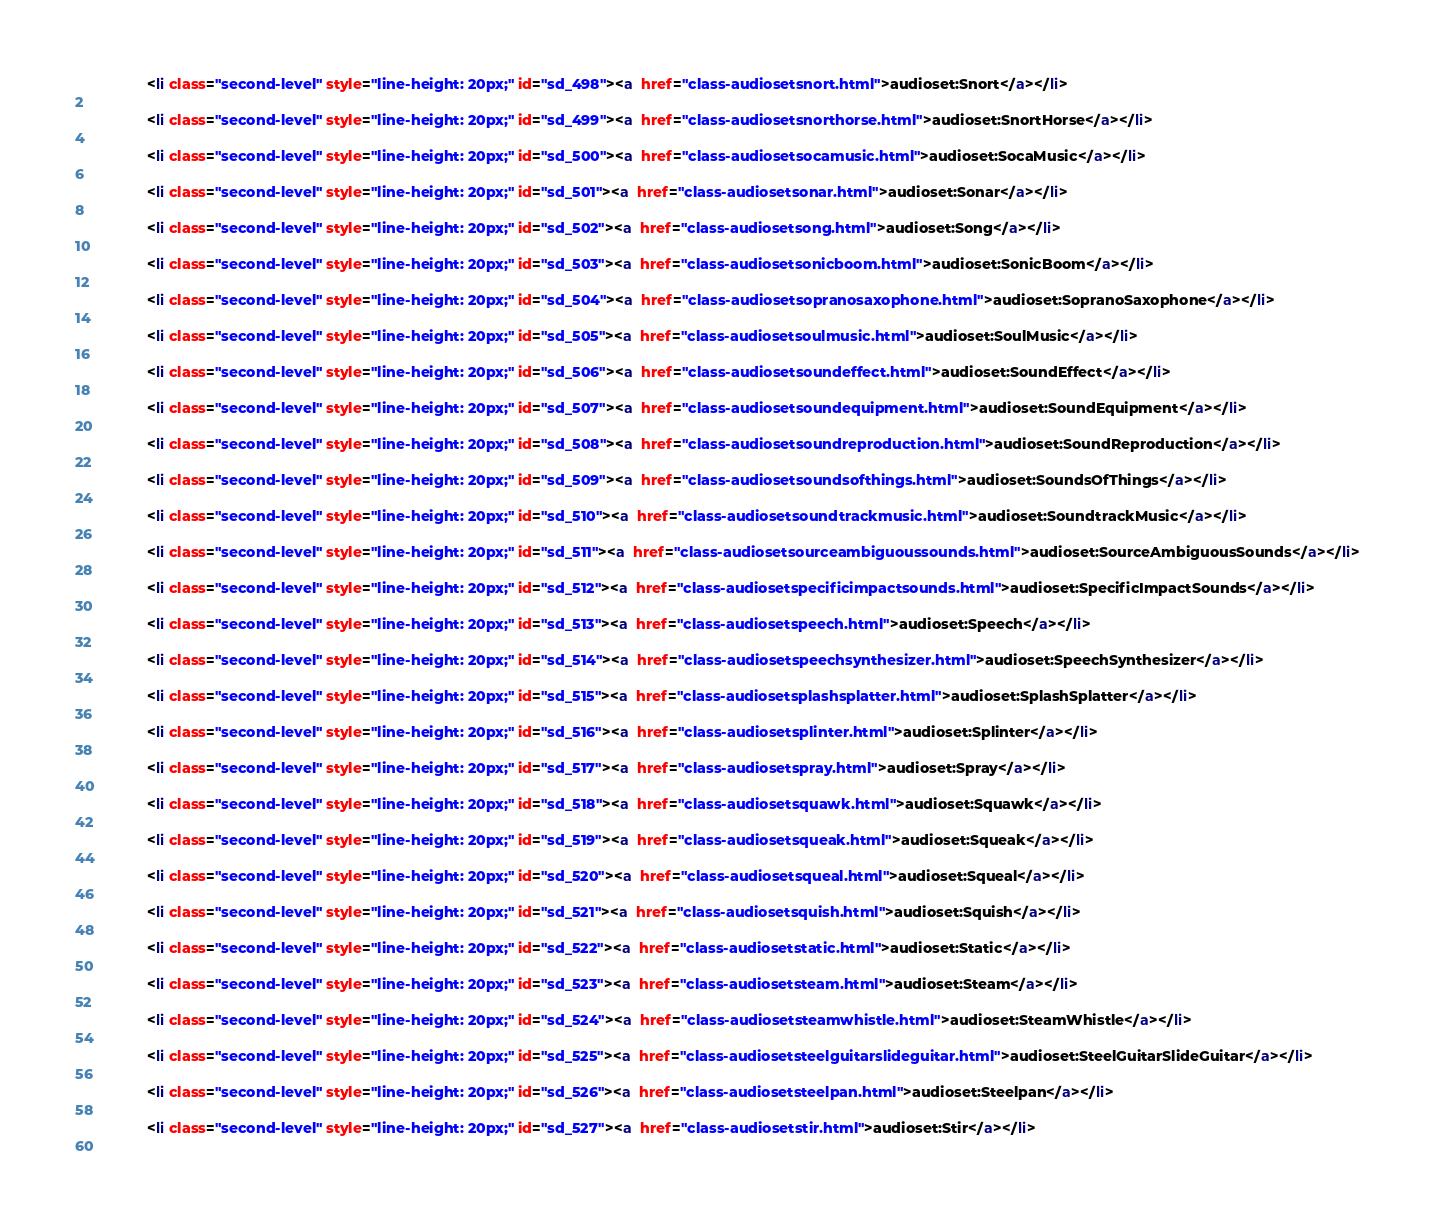Convert code to text. <code><loc_0><loc_0><loc_500><loc_500><_HTML_>              <li class="second-level" style="line-height: 20px;" id="sd_498"><a  href="class-audiosetsnort.html">audioset:Snort</a></li>
          
              <li class="second-level" style="line-height: 20px;" id="sd_499"><a  href="class-audiosetsnorthorse.html">audioset:SnortHorse</a></li>
          
              <li class="second-level" style="line-height: 20px;" id="sd_500"><a  href="class-audiosetsocamusic.html">audioset:SocaMusic</a></li>
          
              <li class="second-level" style="line-height: 20px;" id="sd_501"><a  href="class-audiosetsonar.html">audioset:Sonar</a></li>
          
              <li class="second-level" style="line-height: 20px;" id="sd_502"><a  href="class-audiosetsong.html">audioset:Song</a></li>
          
              <li class="second-level" style="line-height: 20px;" id="sd_503"><a  href="class-audiosetsonicboom.html">audioset:SonicBoom</a></li>
          
              <li class="second-level" style="line-height: 20px;" id="sd_504"><a  href="class-audiosetsopranosaxophone.html">audioset:SopranoSaxophone</a></li>
          
              <li class="second-level" style="line-height: 20px;" id="sd_505"><a  href="class-audiosetsoulmusic.html">audioset:SoulMusic</a></li>
          
              <li class="second-level" style="line-height: 20px;" id="sd_506"><a  href="class-audiosetsoundeffect.html">audioset:SoundEffect</a></li>
          
              <li class="second-level" style="line-height: 20px;" id="sd_507"><a  href="class-audiosetsoundequipment.html">audioset:SoundEquipment</a></li>
          
              <li class="second-level" style="line-height: 20px;" id="sd_508"><a  href="class-audiosetsoundreproduction.html">audioset:SoundReproduction</a></li>
          
              <li class="second-level" style="line-height: 20px;" id="sd_509"><a  href="class-audiosetsoundsofthings.html">audioset:SoundsOfThings</a></li>
          
              <li class="second-level" style="line-height: 20px;" id="sd_510"><a  href="class-audiosetsoundtrackmusic.html">audioset:SoundtrackMusic</a></li>
          
              <li class="second-level" style="line-height: 20px;" id="sd_511"><a  href="class-audiosetsourceambiguoussounds.html">audioset:SourceAmbiguousSounds</a></li>
          
              <li class="second-level" style="line-height: 20px;" id="sd_512"><a  href="class-audiosetspecificimpactsounds.html">audioset:SpecificImpactSounds</a></li>
          
              <li class="second-level" style="line-height: 20px;" id="sd_513"><a  href="class-audiosetspeech.html">audioset:Speech</a></li>
          
              <li class="second-level" style="line-height: 20px;" id="sd_514"><a  href="class-audiosetspeechsynthesizer.html">audioset:SpeechSynthesizer</a></li>
          
              <li class="second-level" style="line-height: 20px;" id="sd_515"><a  href="class-audiosetsplashsplatter.html">audioset:SplashSplatter</a></li>
          
              <li class="second-level" style="line-height: 20px;" id="sd_516"><a  href="class-audiosetsplinter.html">audioset:Splinter</a></li>
          
              <li class="second-level" style="line-height: 20px;" id="sd_517"><a  href="class-audiosetspray.html">audioset:Spray</a></li>
          
              <li class="second-level" style="line-height: 20px;" id="sd_518"><a  href="class-audiosetsquawk.html">audioset:Squawk</a></li>
          
              <li class="second-level" style="line-height: 20px;" id="sd_519"><a  href="class-audiosetsqueak.html">audioset:Squeak</a></li>
          
              <li class="second-level" style="line-height: 20px;" id="sd_520"><a  href="class-audiosetsqueal.html">audioset:Squeal</a></li>
          
              <li class="second-level" style="line-height: 20px;" id="sd_521"><a  href="class-audiosetsquish.html">audioset:Squish</a></li>
          
              <li class="second-level" style="line-height: 20px;" id="sd_522"><a  href="class-audiosetstatic.html">audioset:Static</a></li>
          
              <li class="second-level" style="line-height: 20px;" id="sd_523"><a  href="class-audiosetsteam.html">audioset:Steam</a></li>
          
              <li class="second-level" style="line-height: 20px;" id="sd_524"><a  href="class-audiosetsteamwhistle.html">audioset:SteamWhistle</a></li>
          
              <li class="second-level" style="line-height: 20px;" id="sd_525"><a  href="class-audiosetsteelguitarslideguitar.html">audioset:SteelGuitarSlideGuitar</a></li>
          
              <li class="second-level" style="line-height: 20px;" id="sd_526"><a  href="class-audiosetsteelpan.html">audioset:Steelpan</a></li>
          
              <li class="second-level" style="line-height: 20px;" id="sd_527"><a  href="class-audiosetstir.html">audioset:Stir</a></li>
          </code> 